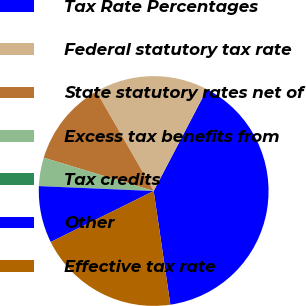Convert chart to OTSL. <chart><loc_0><loc_0><loc_500><loc_500><pie_chart><fcel>Tax Rate Percentages<fcel>Federal statutory tax rate<fcel>State statutory rates net of<fcel>Excess tax benefits from<fcel>Tax credits<fcel>Other<fcel>Effective tax rate<nl><fcel>40.0%<fcel>16.0%<fcel>12.0%<fcel>4.0%<fcel>0.0%<fcel>8.0%<fcel>20.0%<nl></chart> 